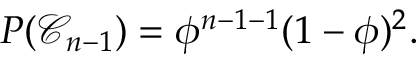<formula> <loc_0><loc_0><loc_500><loc_500>P ( \mathcal { C } _ { n - 1 } ) = \phi ^ { n - 1 - 1 } ( 1 - \phi ) ^ { 2 } .</formula> 